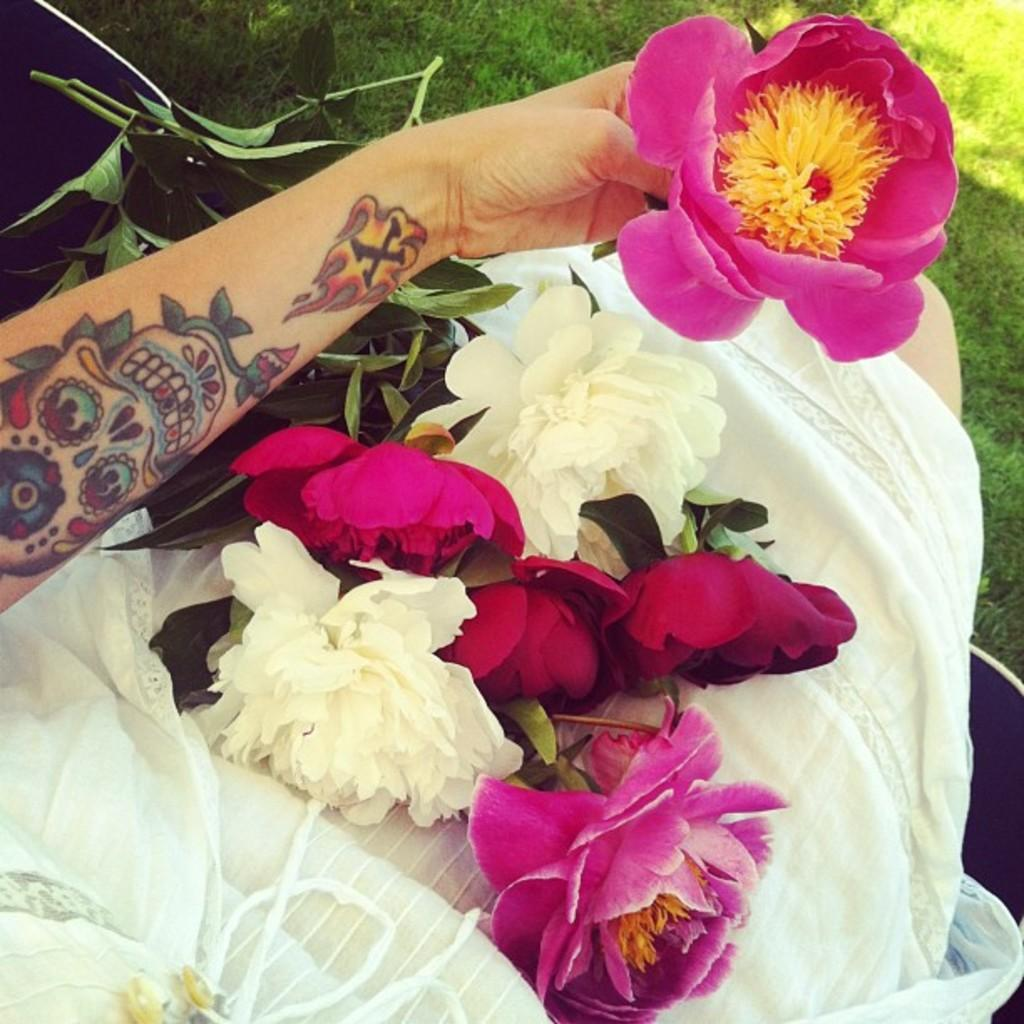Who or what is present in the image? There is a person in the image. What type of plants can be seen in the image? There are flowers and leaves in the image. What is the ground made of in the image? There is grass at the bottom of the image. What type of territory is being claimed by the person in the image? There is no indication in the image that the person is claiming any territory. 